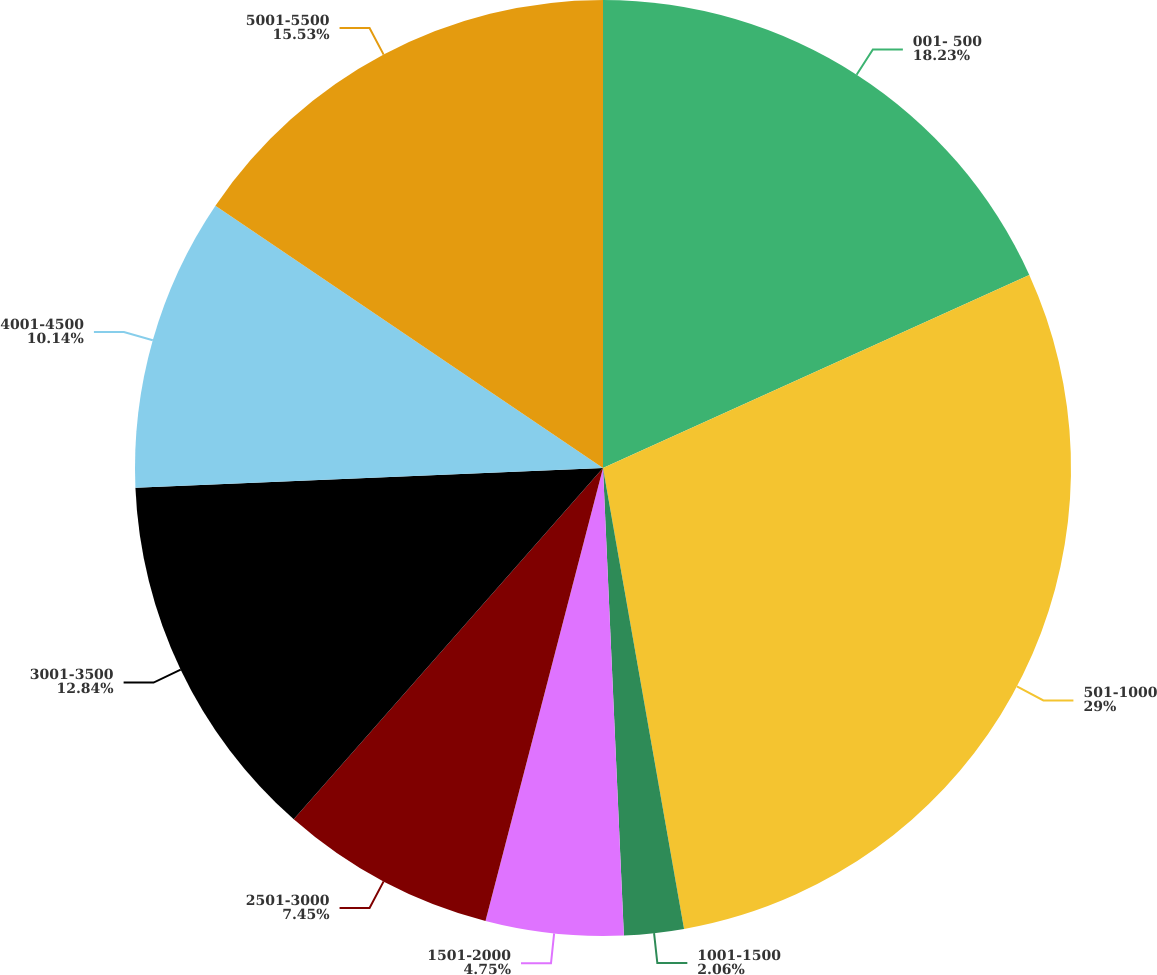<chart> <loc_0><loc_0><loc_500><loc_500><pie_chart><fcel>001- 500<fcel>501-1000<fcel>1001-1500<fcel>1501-2000<fcel>2501-3000<fcel>3001-3500<fcel>4001-4500<fcel>5001-5500<nl><fcel>18.23%<fcel>29.0%<fcel>2.06%<fcel>4.75%<fcel>7.45%<fcel>12.84%<fcel>10.14%<fcel>15.53%<nl></chart> 